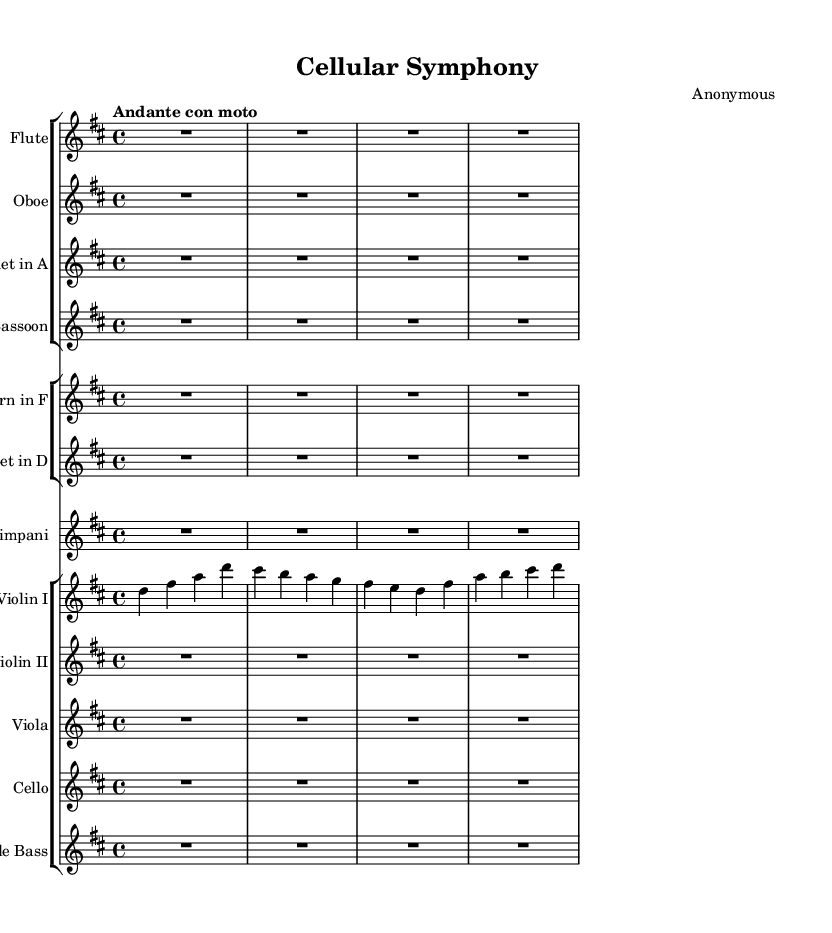What is the key signature of this music? The key signature indicated by the 'k' command in the global section is D major, which includes two sharps (F# and C#).
Answer: D major What is the tempo marking for this piece? The tempo marking is shown at the beginning as "Andante con moto," indicating a moderate tempo that has a slightly quicker pace than Andante.
Answer: Andante con moto How many staves are there for string instruments? In the score section, there are four staves designated for string instruments: Violin I, Violin II, Viola, Cello, and Double Bass. Counting these gives a total of five staves.
Answer: Five What is the time signature of this music? The time signature is indicated at the beginning in the global section as 4/4, which means there are four beats per measure.
Answer: 4/4 Which instrument has the first music fragment in this composition? The first music fragment is played by Violin I, indicated by the specific notation for that instrument appearing first in the score.
Answer: Violin I How many different woodwind instruments are present in the piece? The score includes four woodwind instruments: Flute, Oboe, Clarinet in A, and Bassoon. Counting them provides a total of four woodwind instruments.
Answer: Four 